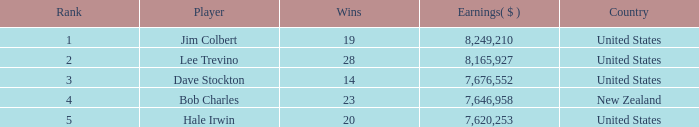How much have players earned with 14 wins ranked below 3? 0.0. 